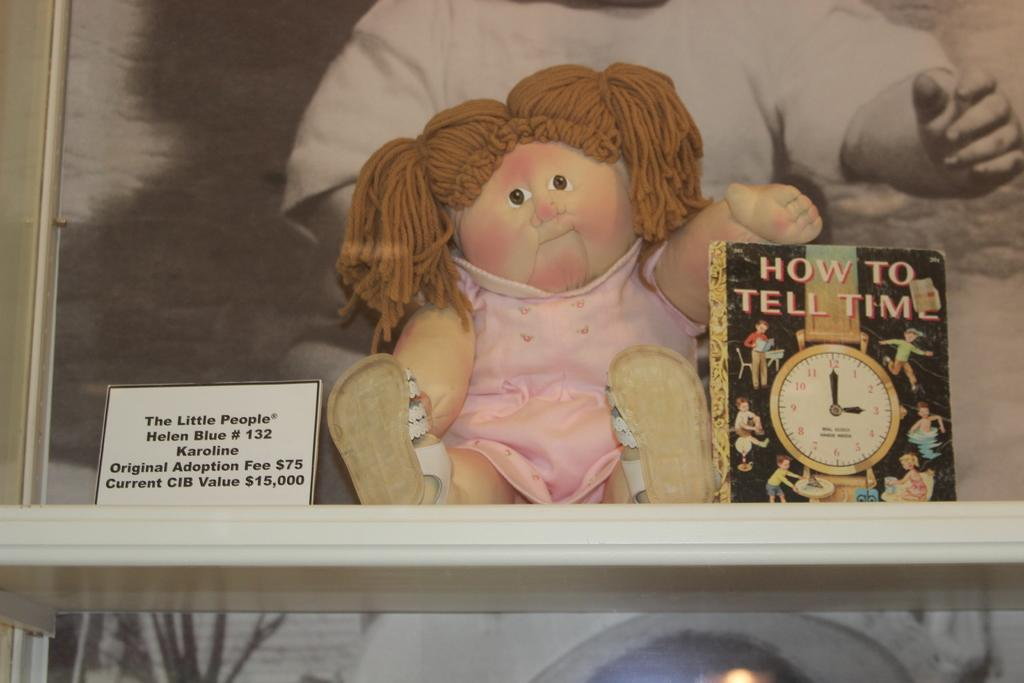<image>
Share a concise interpretation of the image provided. A doll on a shelf beside a book about how to tell time. 